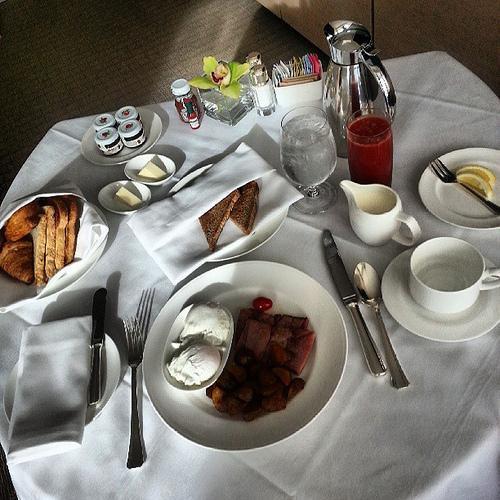How many glasses are on the table?
Give a very brief answer. 2. 